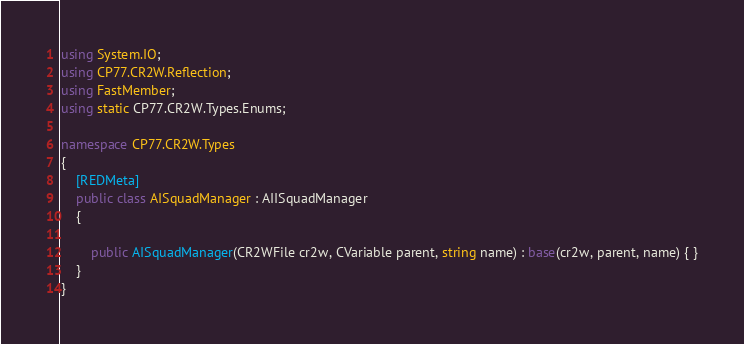<code> <loc_0><loc_0><loc_500><loc_500><_C#_>using System.IO;
using CP77.CR2W.Reflection;
using FastMember;
using static CP77.CR2W.Types.Enums;

namespace CP77.CR2W.Types
{
	[REDMeta]
	public class AISquadManager : AIISquadManager
	{

		public AISquadManager(CR2WFile cr2w, CVariable parent, string name) : base(cr2w, parent, name) { }
	}
}
</code> 